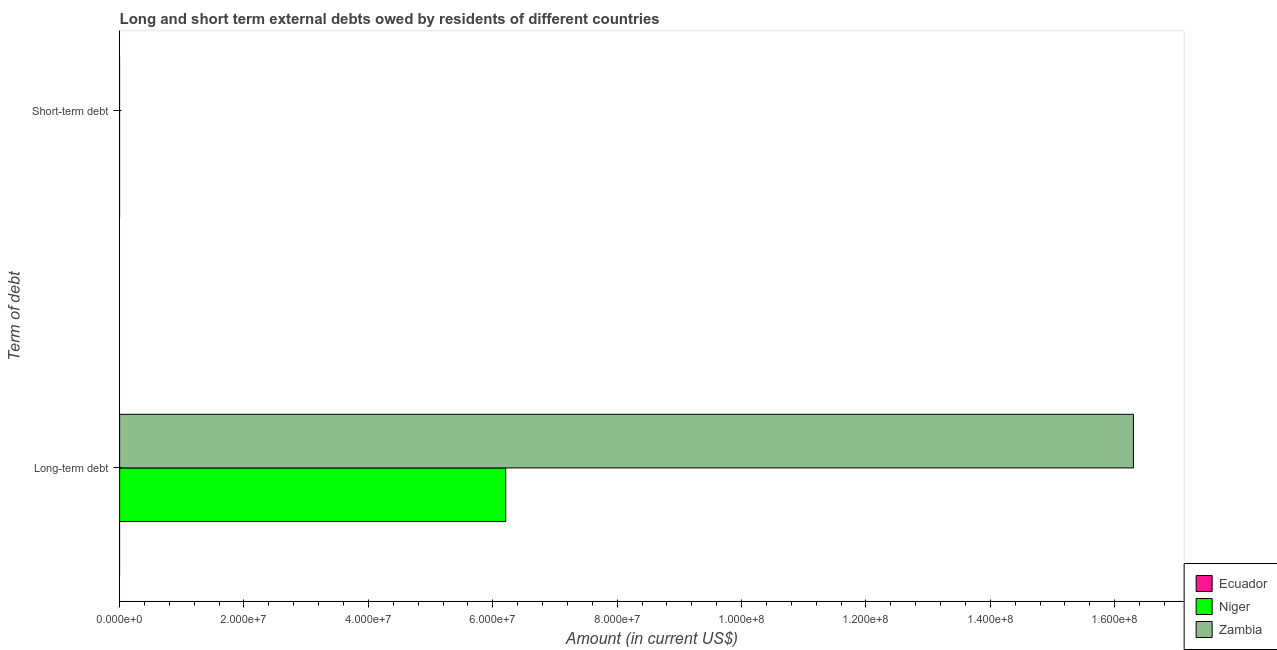How many different coloured bars are there?
Make the answer very short. 2. Are the number of bars per tick equal to the number of legend labels?
Ensure brevity in your answer.  No. Are the number of bars on each tick of the Y-axis equal?
Offer a terse response. No. How many bars are there on the 2nd tick from the top?
Offer a terse response. 2. What is the label of the 2nd group of bars from the top?
Make the answer very short. Long-term debt. Across all countries, what is the maximum long-term debts owed by residents?
Your answer should be very brief. 1.63e+08. Across all countries, what is the minimum long-term debts owed by residents?
Provide a succinct answer. 0. In which country was the long-term debts owed by residents maximum?
Offer a very short reply. Zambia. What is the total short-term debts owed by residents in the graph?
Keep it short and to the point. 0. What is the difference between the short-term debts owed by residents in Ecuador and the long-term debts owed by residents in Niger?
Provide a succinct answer. -6.21e+07. In how many countries, is the long-term debts owed by residents greater than 120000000 US$?
Keep it short and to the point. 1. What is the ratio of the long-term debts owed by residents in Zambia to that in Niger?
Offer a terse response. 2.63. Is the long-term debts owed by residents in Niger less than that in Zambia?
Your answer should be very brief. Yes. Are all the bars in the graph horizontal?
Provide a succinct answer. Yes. What is the difference between two consecutive major ticks on the X-axis?
Your answer should be very brief. 2.00e+07. Does the graph contain any zero values?
Make the answer very short. Yes. Does the graph contain grids?
Keep it short and to the point. No. Where does the legend appear in the graph?
Keep it short and to the point. Bottom right. What is the title of the graph?
Make the answer very short. Long and short term external debts owed by residents of different countries. What is the label or title of the Y-axis?
Make the answer very short. Term of debt. What is the Amount (in current US$) in Niger in Long-term debt?
Offer a terse response. 6.21e+07. What is the Amount (in current US$) in Zambia in Long-term debt?
Ensure brevity in your answer.  1.63e+08. What is the Amount (in current US$) in Zambia in Short-term debt?
Ensure brevity in your answer.  0. Across all Term of debt, what is the maximum Amount (in current US$) in Niger?
Your answer should be very brief. 6.21e+07. Across all Term of debt, what is the maximum Amount (in current US$) of Zambia?
Make the answer very short. 1.63e+08. Across all Term of debt, what is the minimum Amount (in current US$) of Zambia?
Make the answer very short. 0. What is the total Amount (in current US$) of Ecuador in the graph?
Provide a short and direct response. 0. What is the total Amount (in current US$) in Niger in the graph?
Make the answer very short. 6.21e+07. What is the total Amount (in current US$) of Zambia in the graph?
Your answer should be very brief. 1.63e+08. What is the average Amount (in current US$) in Niger per Term of debt?
Your answer should be compact. 3.10e+07. What is the average Amount (in current US$) of Zambia per Term of debt?
Provide a short and direct response. 8.15e+07. What is the difference between the Amount (in current US$) of Niger and Amount (in current US$) of Zambia in Long-term debt?
Ensure brevity in your answer.  -1.01e+08. What is the difference between the highest and the lowest Amount (in current US$) in Niger?
Give a very brief answer. 6.21e+07. What is the difference between the highest and the lowest Amount (in current US$) in Zambia?
Your answer should be compact. 1.63e+08. 